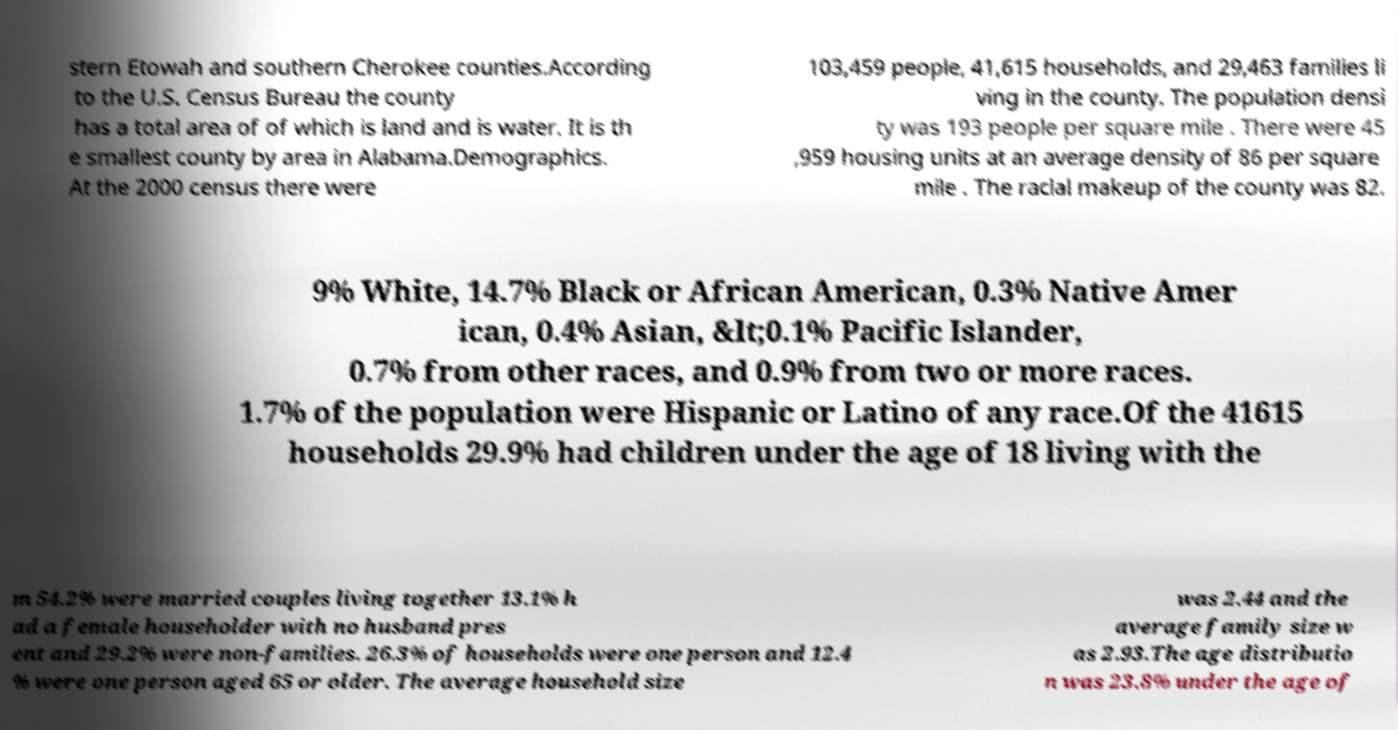What messages or text are displayed in this image? I need them in a readable, typed format. stern Etowah and southern Cherokee counties.According to the U.S. Census Bureau the county has a total area of of which is land and is water. It is th e smallest county by area in Alabama.Demographics. At the 2000 census there were 103,459 people, 41,615 households, and 29,463 families li ving in the county. The population densi ty was 193 people per square mile . There were 45 ,959 housing units at an average density of 86 per square mile . The racial makeup of the county was 82. 9% White, 14.7% Black or African American, 0.3% Native Amer ican, 0.4% Asian, &lt;0.1% Pacific Islander, 0.7% from other races, and 0.9% from two or more races. 1.7% of the population were Hispanic or Latino of any race.Of the 41615 households 29.9% had children under the age of 18 living with the m 54.2% were married couples living together 13.1% h ad a female householder with no husband pres ent and 29.2% were non-families. 26.3% of households were one person and 12.4 % were one person aged 65 or older. The average household size was 2.44 and the average family size w as 2.93.The age distributio n was 23.8% under the age of 